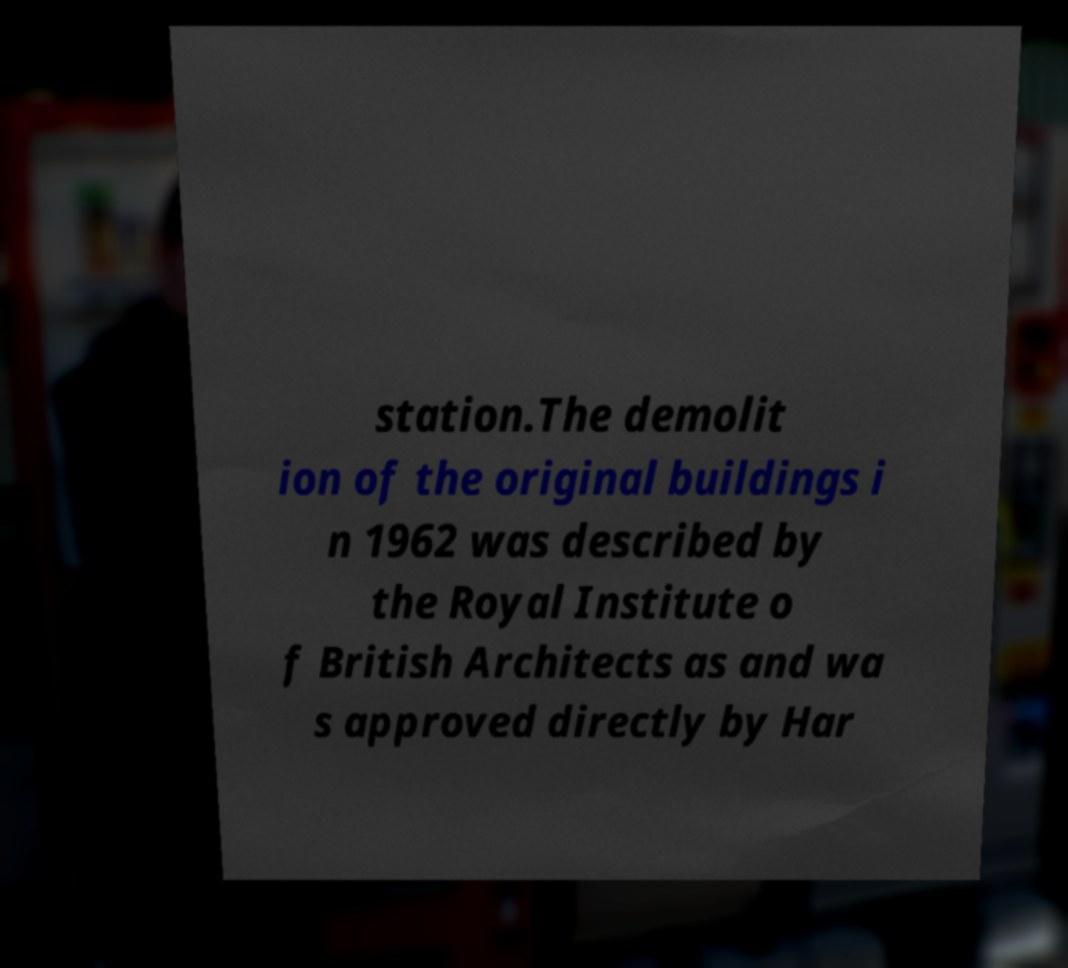Please read and relay the text visible in this image. What does it say? station.The demolit ion of the original buildings i n 1962 was described by the Royal Institute o f British Architects as and wa s approved directly by Har 